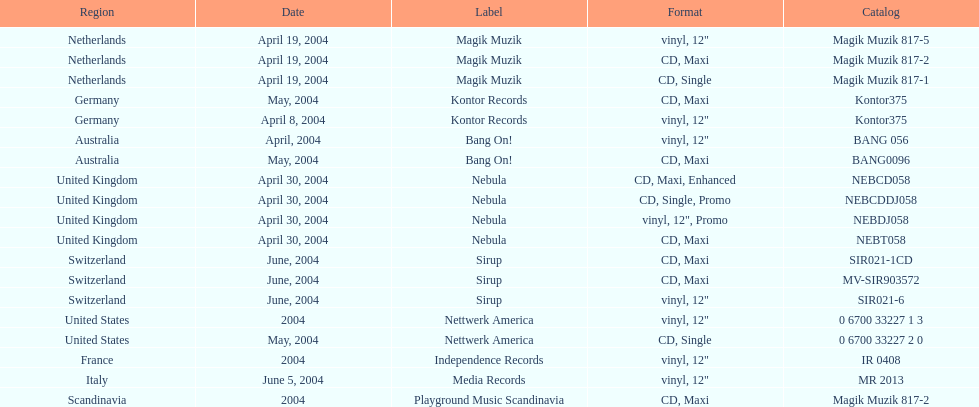What tag was italy assigned? Media Records. 